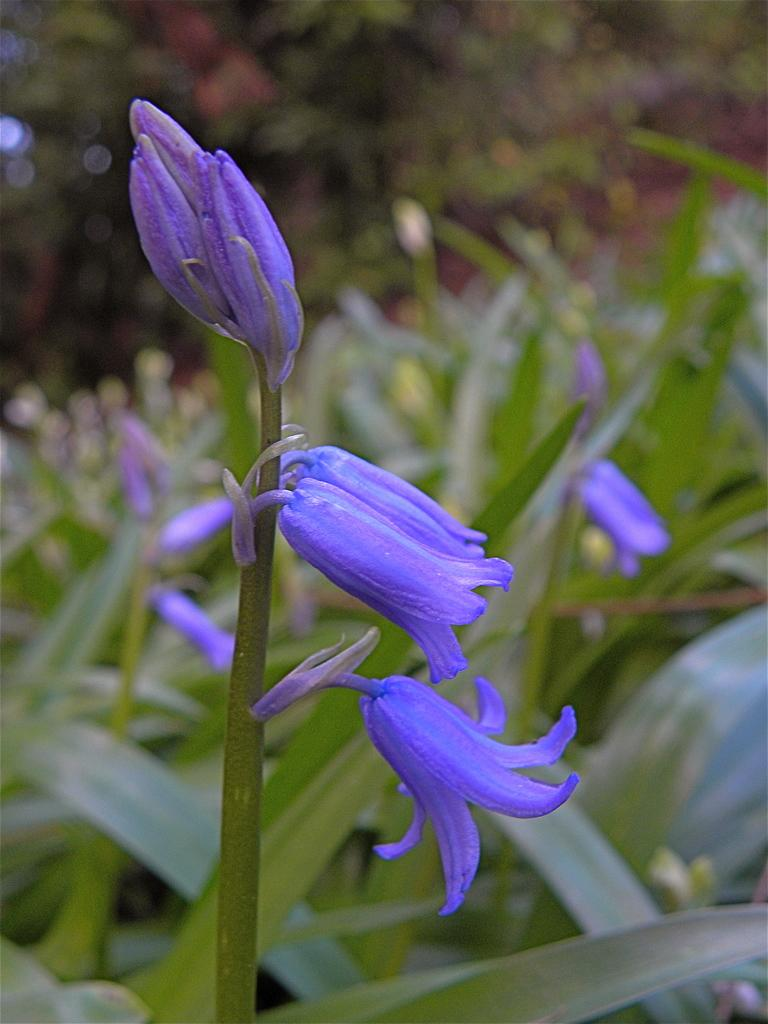What type of living organisms can be seen in the image? Plants, leaves, and flowers are visible in the image. Can you describe the specific parts of the plants that are present? Leaves and flowers are visible in the image. What might be the purpose of the flowers in the image? The flowers may be for decoration or to attract pollinators. How much was the payment for the waves on the toe in the image? There is no payment, waves, or toe present in the image; it features plants, leaves, and flowers. 